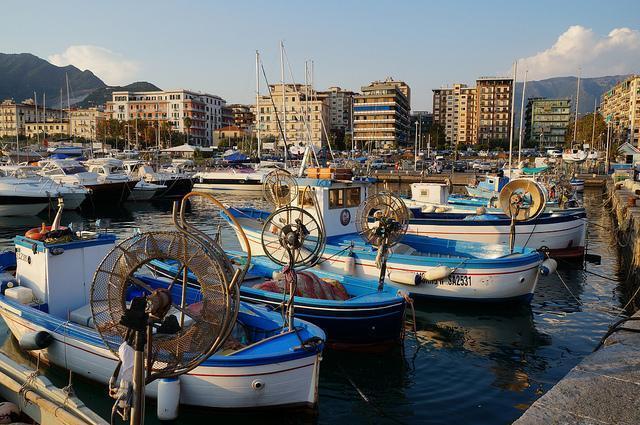How many boats are there?
Give a very brief answer. 6. 